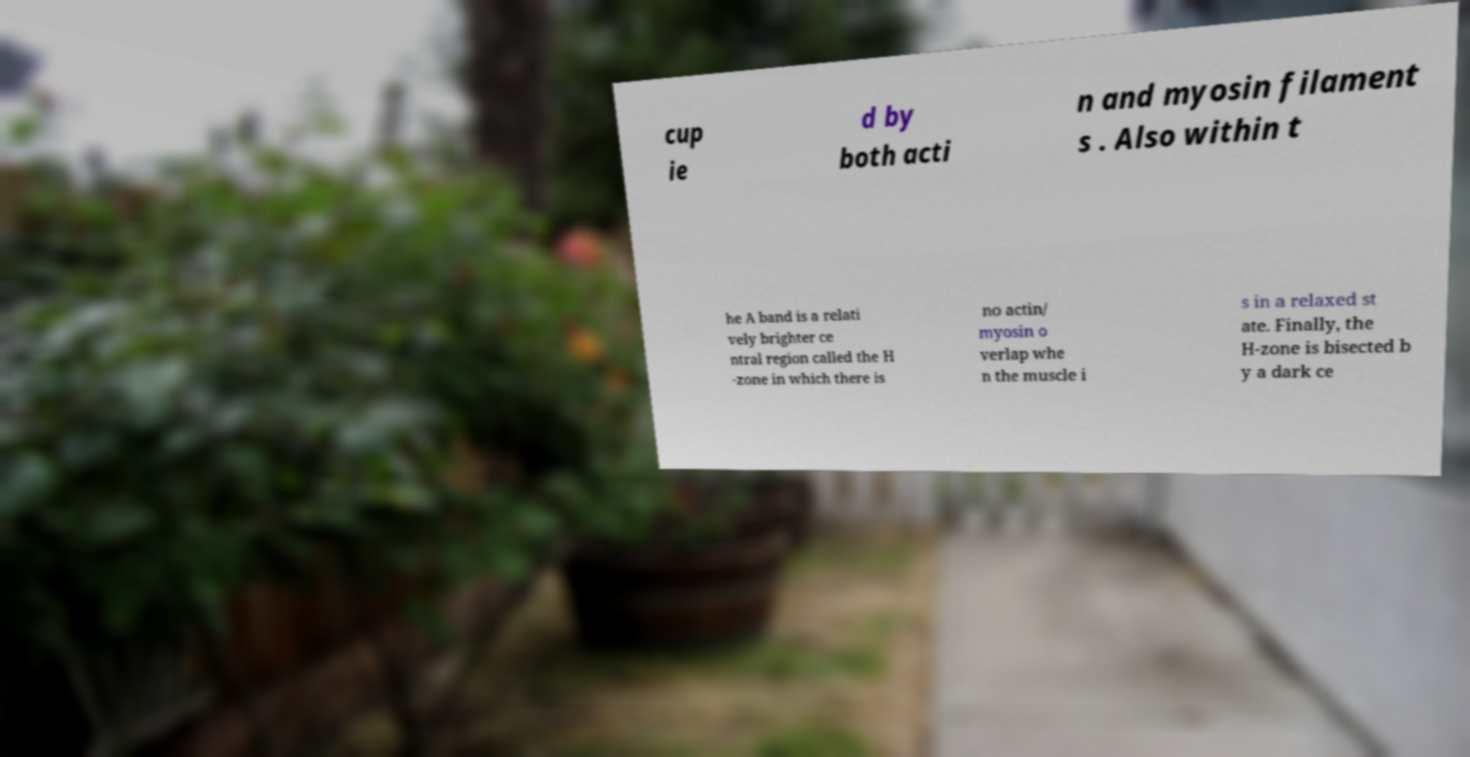I need the written content from this picture converted into text. Can you do that? cup ie d by both acti n and myosin filament s . Also within t he A band is a relati vely brighter ce ntral region called the H -zone in which there is no actin/ myosin o verlap whe n the muscle i s in a relaxed st ate. Finally, the H-zone is bisected b y a dark ce 